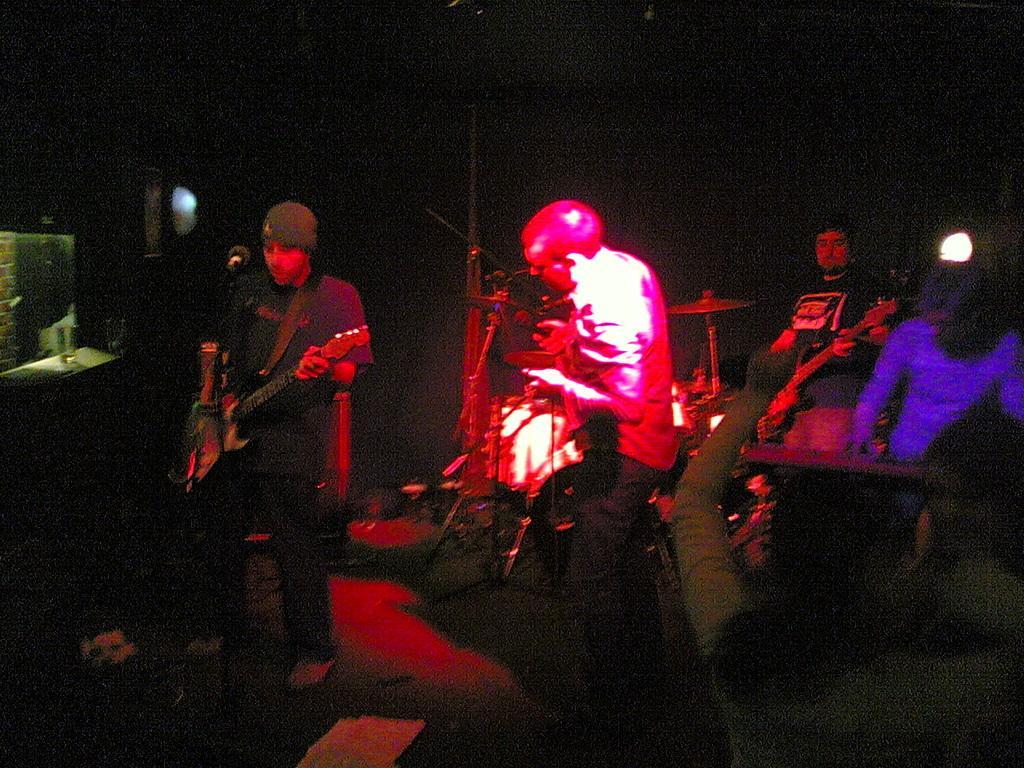Could you give a brief overview of what you see in this image? In the image we can see there are people who are standing and playing musical instruments. 